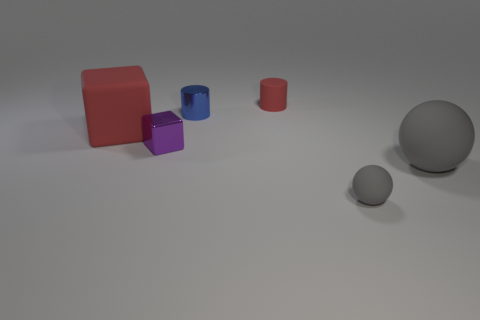Add 2 large red cubes. How many objects exist? 8 Subtract all blocks. How many objects are left? 4 Add 1 tiny red rubber things. How many tiny red rubber things exist? 2 Subtract 1 purple blocks. How many objects are left? 5 Subtract all small purple metal blocks. Subtract all tiny shiny objects. How many objects are left? 3 Add 1 rubber blocks. How many rubber blocks are left? 2 